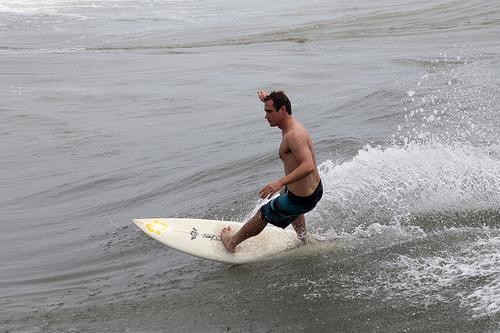How many people are in the picture?
Give a very brief answer. 1. 